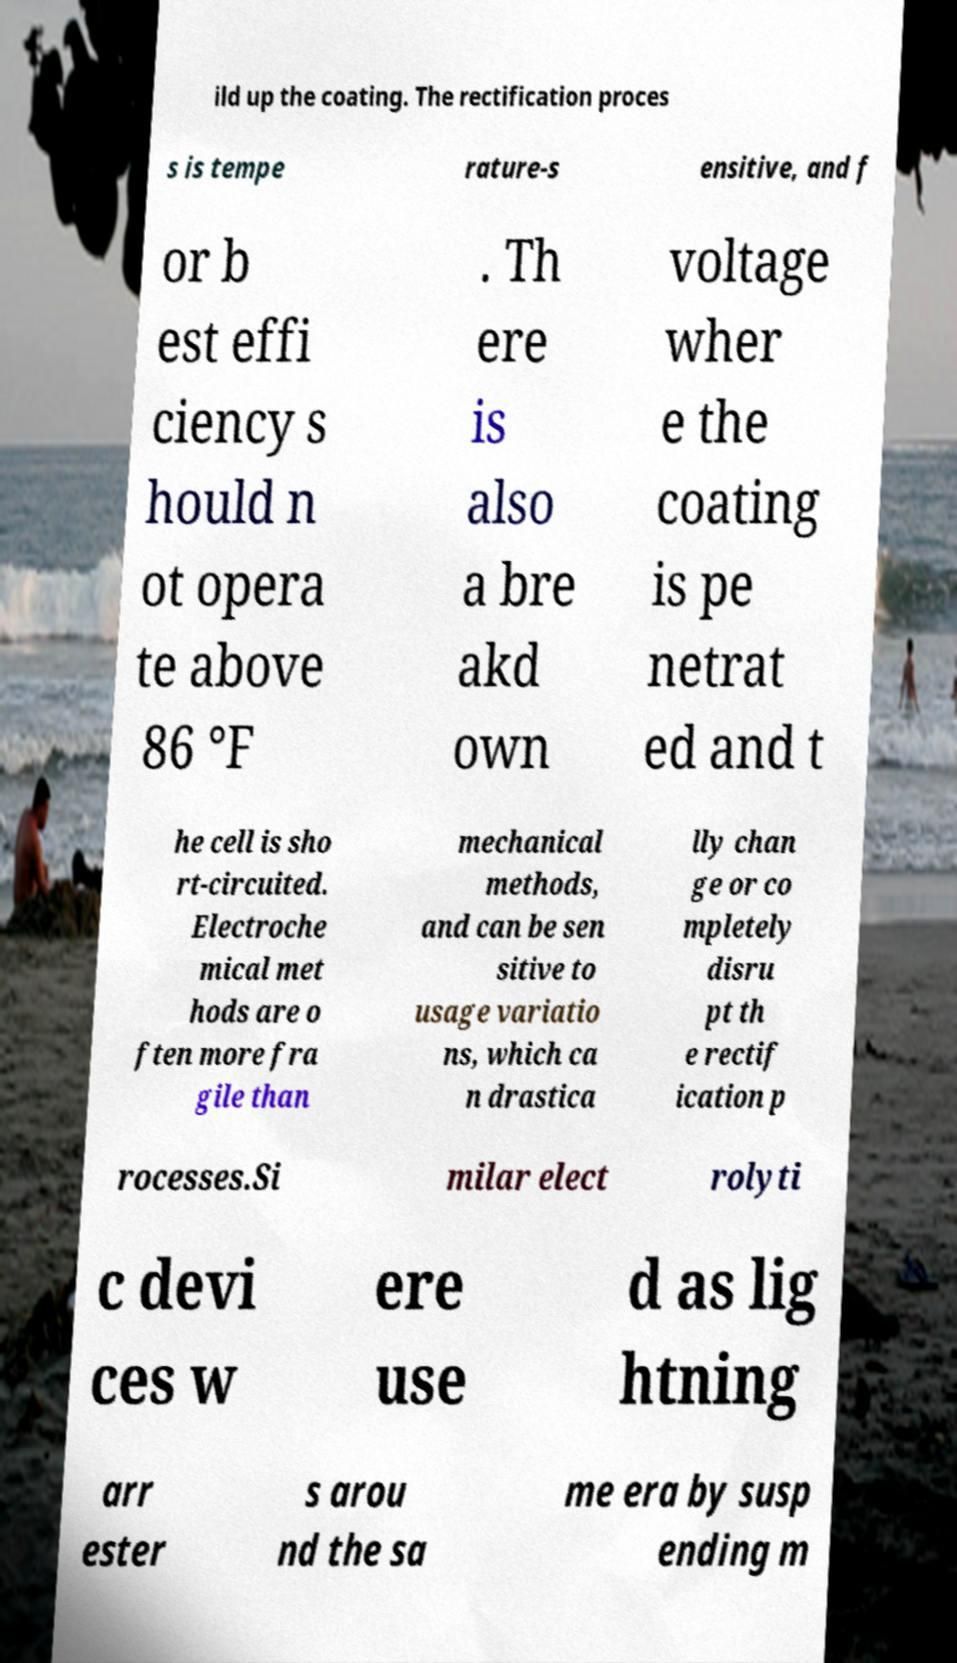What messages or text are displayed in this image? I need them in a readable, typed format. ild up the coating. The rectification proces s is tempe rature-s ensitive, and f or b est effi ciency s hould n ot opera te above 86 °F . Th ere is also a bre akd own voltage wher e the coating is pe netrat ed and t he cell is sho rt-circuited. Electroche mical met hods are o ften more fra gile than mechanical methods, and can be sen sitive to usage variatio ns, which ca n drastica lly chan ge or co mpletely disru pt th e rectif ication p rocesses.Si milar elect rolyti c devi ces w ere use d as lig htning arr ester s arou nd the sa me era by susp ending m 